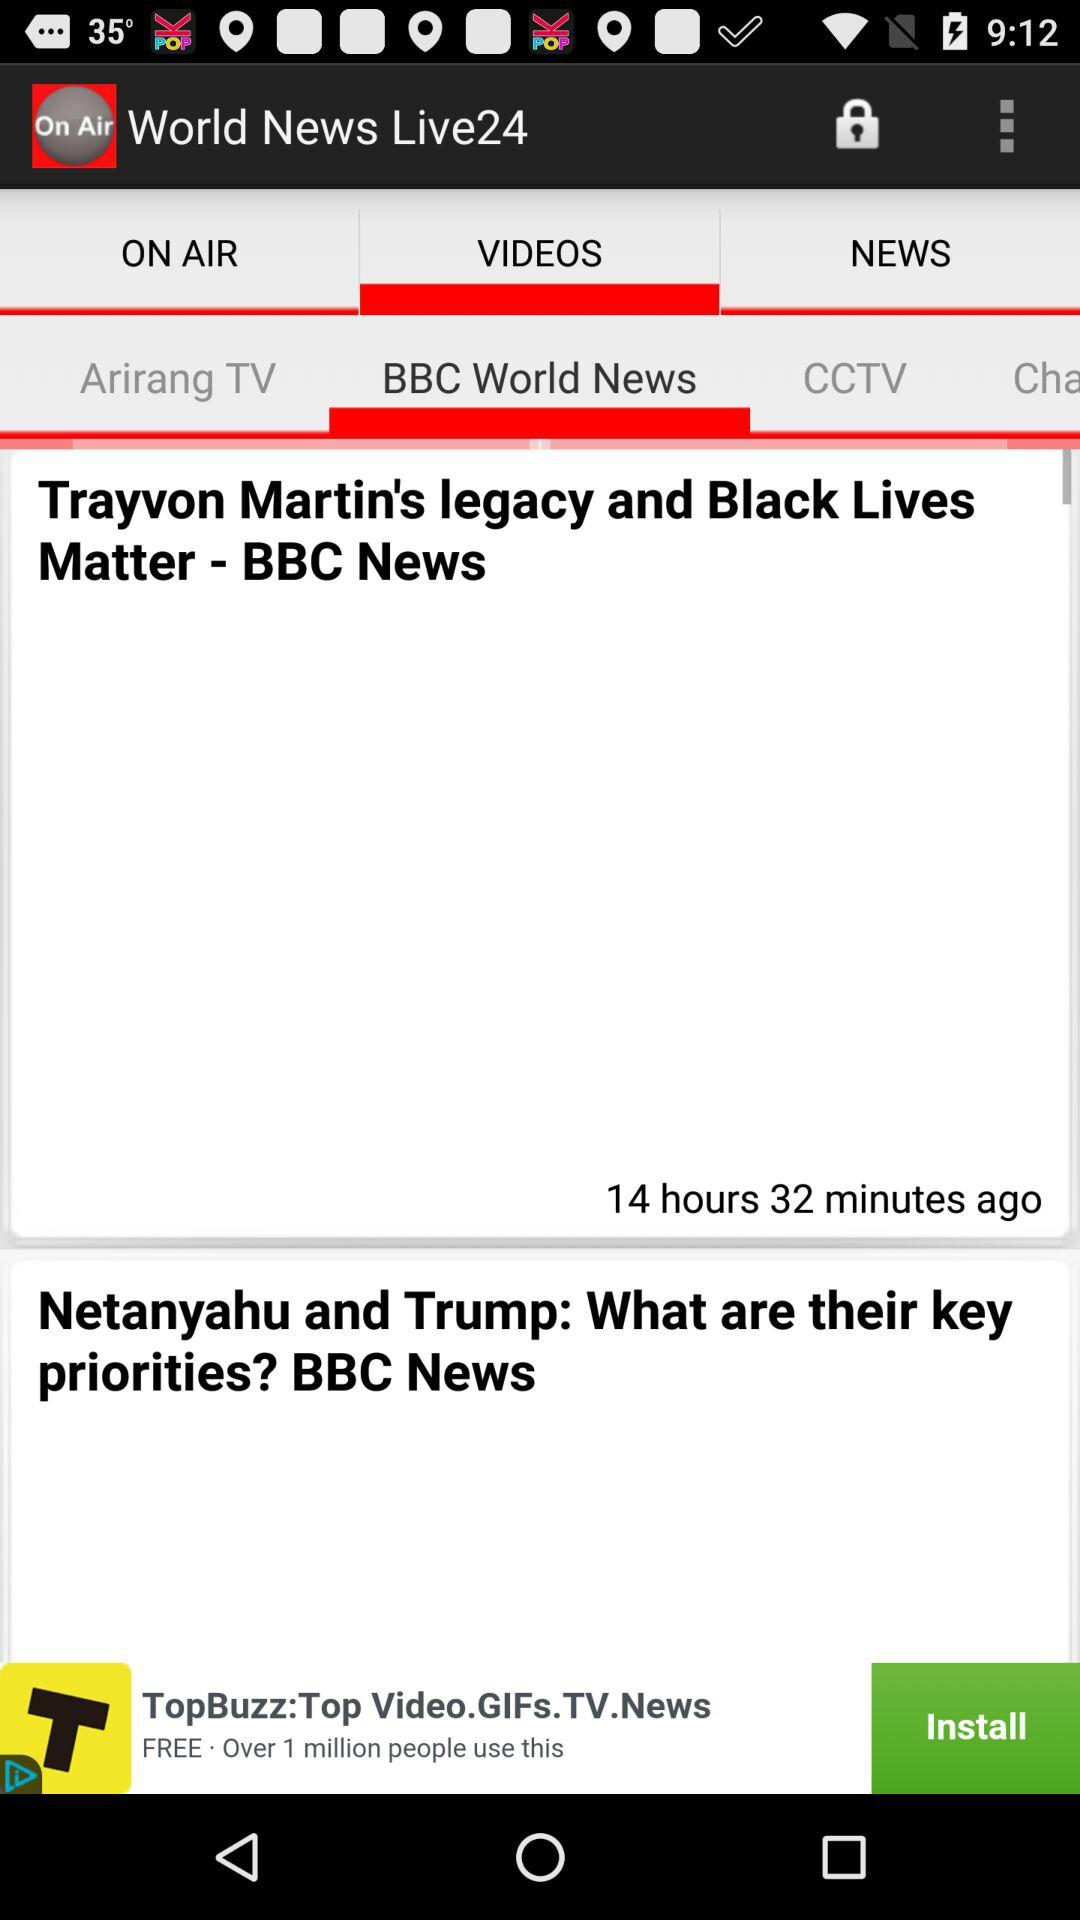Who posted the news about "Netanyahu and Trump"? The news about "Netanyahu and Trump" was posted by BBC News. 